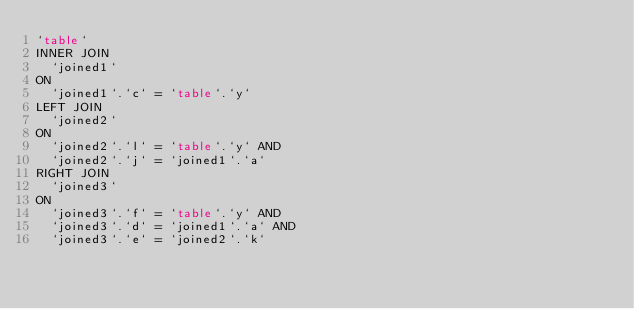Convert code to text. <code><loc_0><loc_0><loc_500><loc_500><_SQL_>`table`
INNER JOIN
  `joined1`
ON
  `joined1`.`c` = `table`.`y`
LEFT JOIN
  `joined2`
ON
  `joined2`.`l` = `table`.`y` AND
  `joined2`.`j` = `joined1`.`a`
RIGHT JOIN
  `joined3`
ON
  `joined3`.`f` = `table`.`y` AND
  `joined3`.`d` = `joined1`.`a` AND
  `joined3`.`e` = `joined2`.`k`</code> 